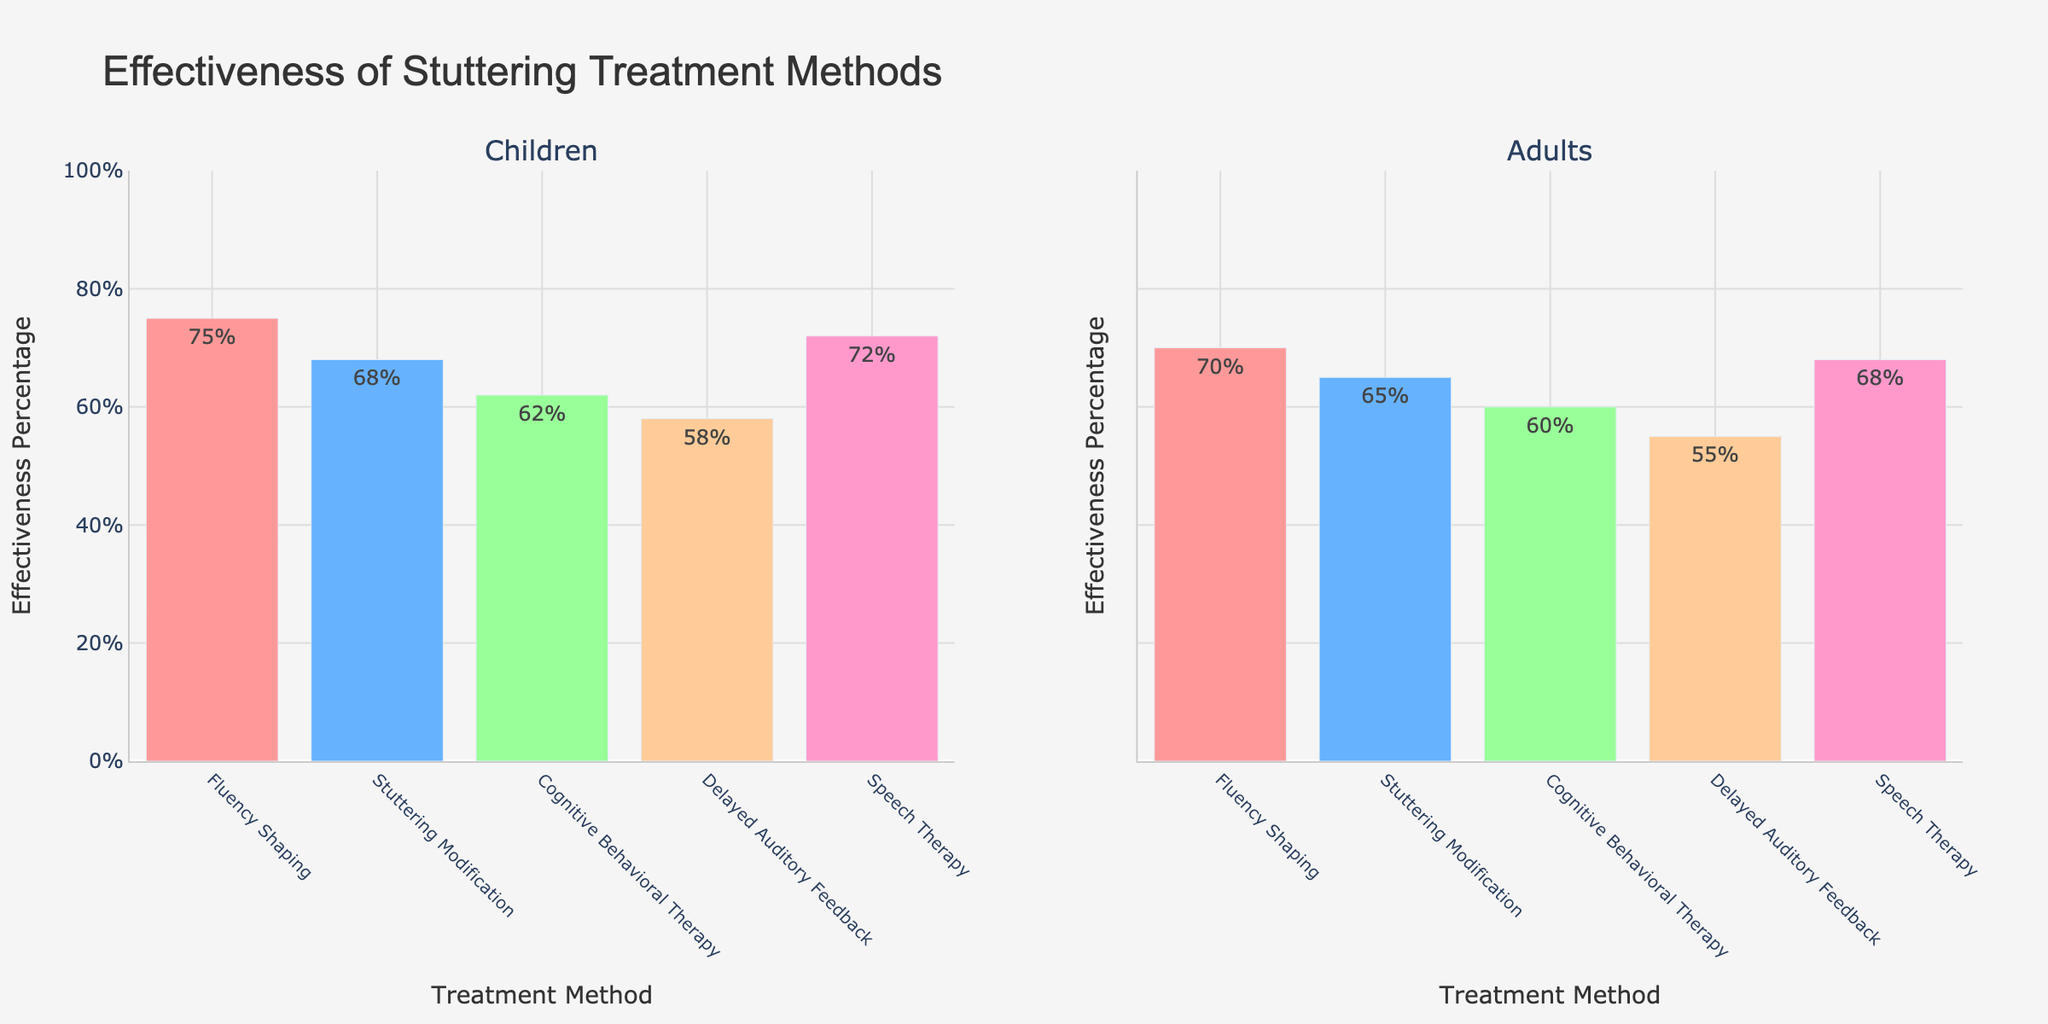What is the overall effectiveness percentage of Fluency Shaping treatment for children? Refer to the left subplot labeled "Children". The Fluency Shaping bar shows an effectiveness percentage of 75%.
Answer: 75% Which age group has the highest effectiveness percentage for Speech Therapy? Look at both subplots for the treatment method labeled "Speech Therapy". Compare the percentages: Children have 72% and Adults have 68%. The Children age group has the higher percentage.
Answer: Children What is the difference in effectiveness percentage between Cognitive Behavioral Therapy and Delayed Auditory Feedback in Adults? In the subplot labeled "Adults", Cognitive Behavioral Therapy has 60% effectiveness, while Delayed Auditory Feedback has 55%. The difference is 60% - 55% = 5%.
Answer: 5% How does the effectiveness of Stuttering Modification compare between children and adults? Compare the heights of the Stuttering Modification bars in both the Children and Adults subplots. Children have an effectiveness of 68%, and Adults have 65%. Children have a higher effectiveness by 3%.
Answer: Children have higher effectiveness by 3% Which treatment method has the lowest effectiveness percentage in children, and what is that percentage? Refer to the left subplot labeled "Children". The bar with the smallest height corresponds to Delayed Auditory Feedback with 58% effectiveness.
Answer: Delayed Auditory Feedback, 58% What is the average effectiveness percentage of all treatments for adults? Add up the effectiveness percentages of all treatment methods for Adults, and then divide by the number of treatments. (70 + 65 + 60 + 55 + 68) / 5 = 63.6%.
Answer: 63.6% What is the combined effectiveness percentage of Fluency Shaping and Speech Therapy in children? For children, Fluency Shaping has 75% and Speech Therapy has 72%. Combine the percentages: 75% + 72% = 147%.
Answer: 147% Which treatment method shows improvement in adults compared to children? Compare percentages for each treatment method across age groups. Fluency Shaping in Children is 75% and in Adults is 70%; Stuttering Modification in Children is 68% and in Adults is 65%; CBT in Children is 62% and in Adults is 60%; DAF in Children is 58% and in Adults is 55%; Speech Therapy in Children is 72% and in Adults is 68%. None of the treatment methods show improvement in adults compared to children.
Answer: None What is the range of effectiveness percentages for children? The effectiveness percentages in children range from 58% to 75%. The range is calculated as 75% - 58% = 17%.
Answer: 17% Which treatment method has the closest effectiveness percentage between children and adults? Compare the effectiveness percentages of each treatment method between the two age groups: Fluency Shaping (75% vs 70%; difference 5%), Stuttering Modification (68% vs 65%; difference 3%), Cognitive Behavioral Therapy (62% vs 60%; difference 2%), Delayed Auditory Feedback (58% vs 55%; difference 3%), and Speech Therapy (72% vs 68%; difference 4%). Cognitive Behavioral Therapy has the smallest difference of 2%.
Answer: Cognitive Behavioral Therapy 